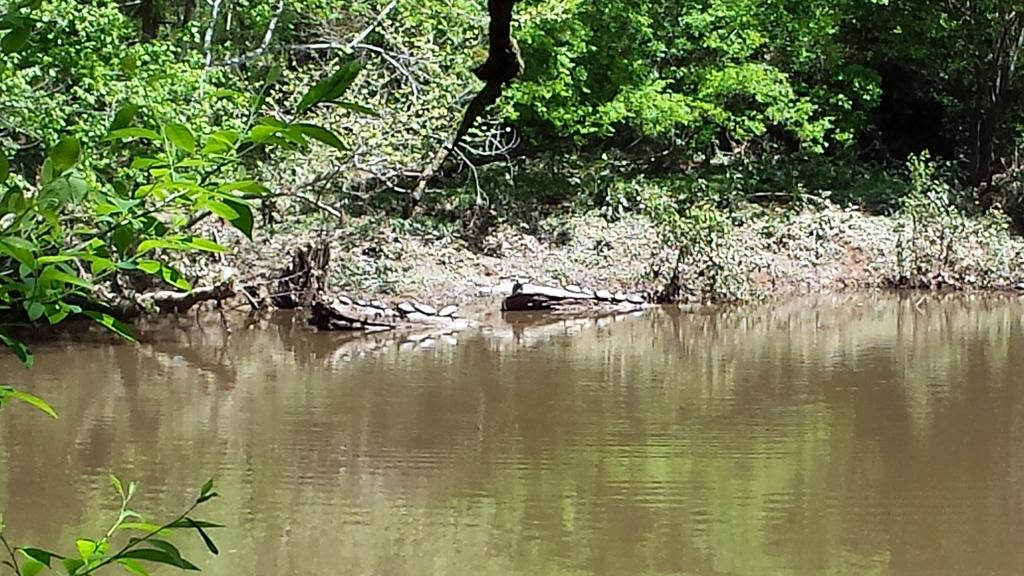What type of vegetation can be seen in the image? There are trees and plants in the image. What natural element is visible in the image? There is water visible in the image. What type of terrain is present in the image? There is sand in the image. Where is the pin located in the image? There is no pin present in the image. What does the mom do in the image? There is no reference to a mom or any person in the image, so it's not possible to answer that question. 